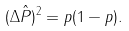<formula> <loc_0><loc_0><loc_500><loc_500>( \Delta \hat { P } ) ^ { 2 } = p ( 1 - p ) .</formula> 